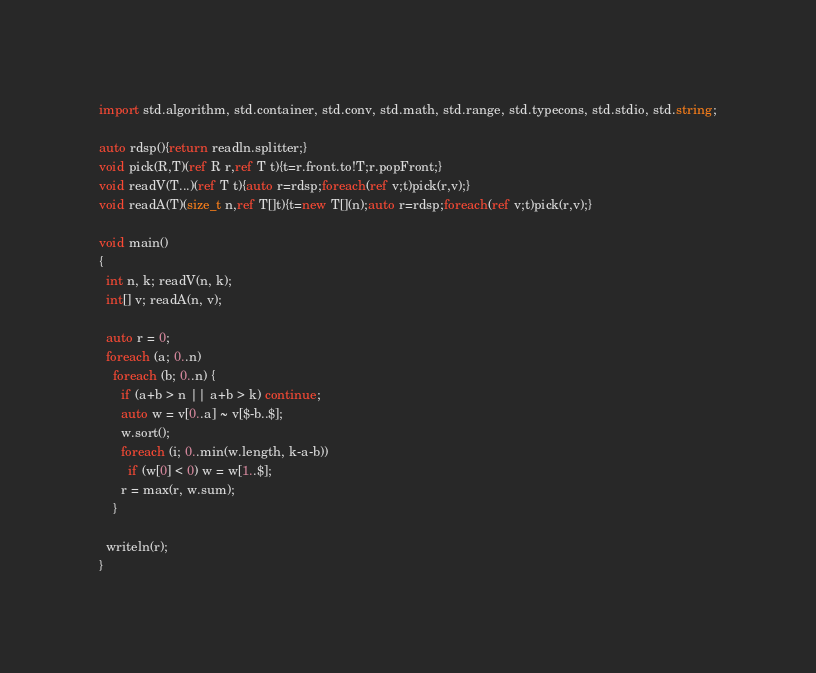<code> <loc_0><loc_0><loc_500><loc_500><_D_>import std.algorithm, std.container, std.conv, std.math, std.range, std.typecons, std.stdio, std.string;

auto rdsp(){return readln.splitter;}
void pick(R,T)(ref R r,ref T t){t=r.front.to!T;r.popFront;}
void readV(T...)(ref T t){auto r=rdsp;foreach(ref v;t)pick(r,v);}
void readA(T)(size_t n,ref T[]t){t=new T[](n);auto r=rdsp;foreach(ref v;t)pick(r,v);}

void main()
{
  int n, k; readV(n, k);
  int[] v; readA(n, v);

  auto r = 0;
  foreach (a; 0..n)
    foreach (b; 0..n) {
      if (a+b > n || a+b > k) continue;
      auto w = v[0..a] ~ v[$-b..$];
      w.sort();
      foreach (i; 0..min(w.length, k-a-b))
        if (w[0] < 0) w = w[1..$];
      r = max(r, w.sum);
    }

  writeln(r);
}
</code> 